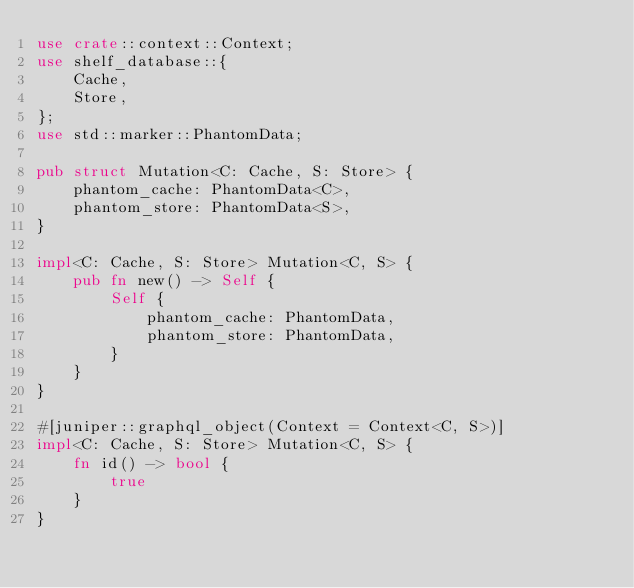Convert code to text. <code><loc_0><loc_0><loc_500><loc_500><_Rust_>use crate::context::Context;
use shelf_database::{
    Cache,
    Store,
};
use std::marker::PhantomData;

pub struct Mutation<C: Cache, S: Store> {
    phantom_cache: PhantomData<C>,
    phantom_store: PhantomData<S>,
}

impl<C: Cache, S: Store> Mutation<C, S> {
    pub fn new() -> Self {
        Self {
            phantom_cache: PhantomData,
            phantom_store: PhantomData,
        }
    }
}

#[juniper::graphql_object(Context = Context<C, S>)]
impl<C: Cache, S: Store> Mutation<C, S> {
    fn id() -> bool {
        true
    }
}
</code> 